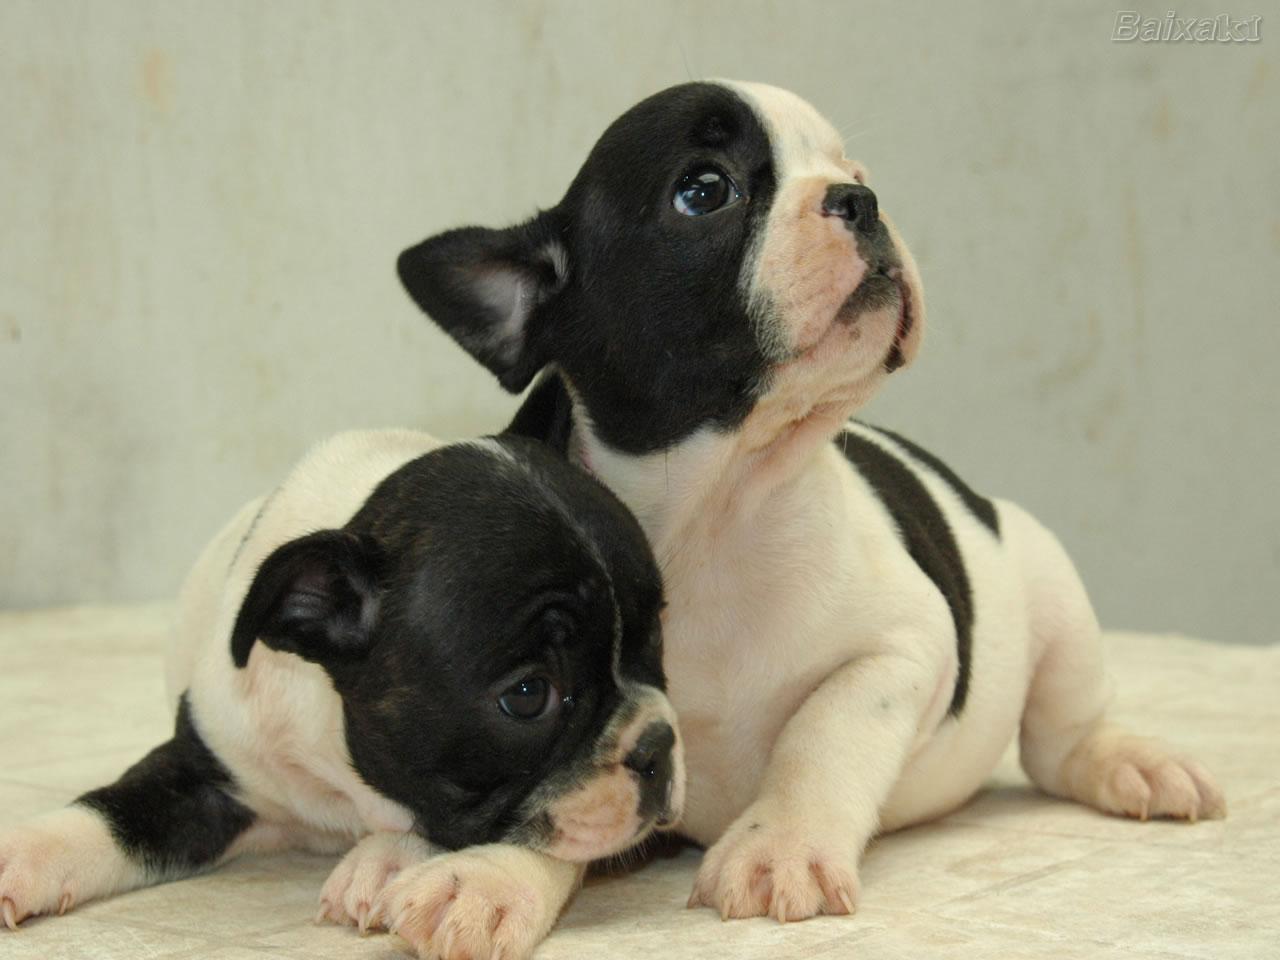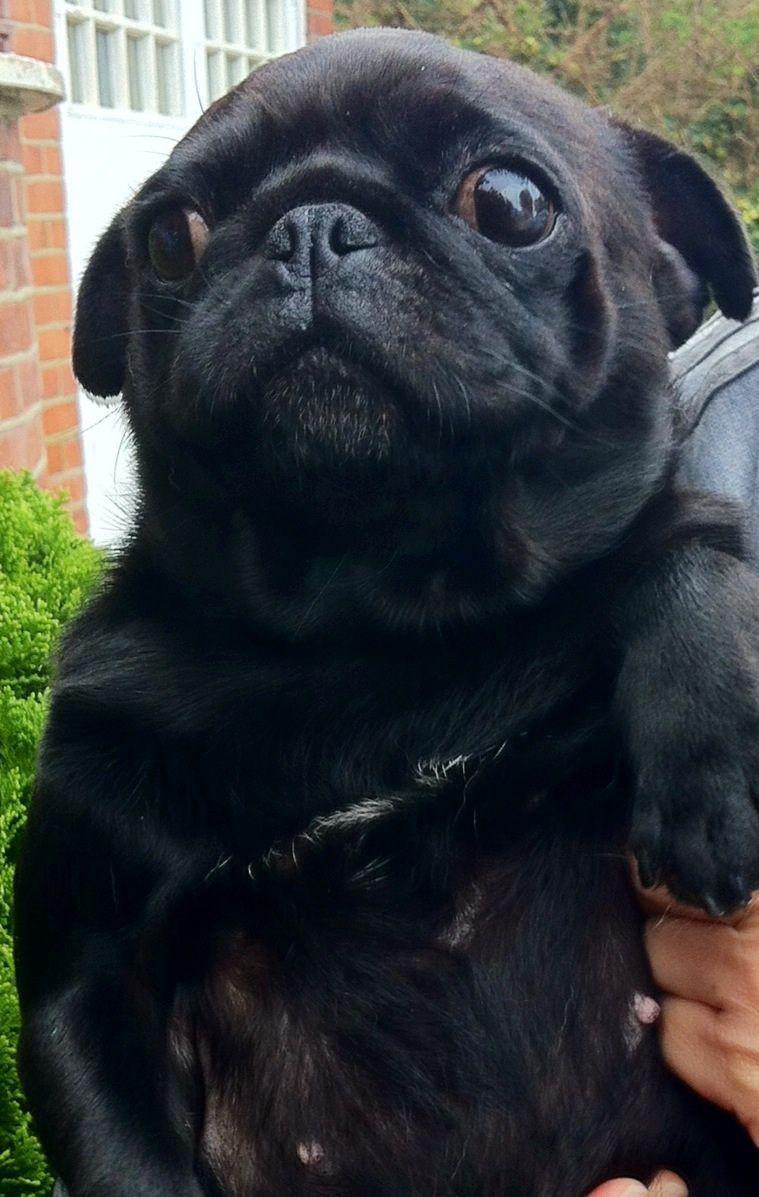The first image is the image on the left, the second image is the image on the right. Given the left and right images, does the statement "There is only one dog in each of the images." hold true? Answer yes or no. No. The first image is the image on the left, the second image is the image on the right. For the images displayed, is the sentence "The right image contains one black pug and a human hand, and no image contains a standing dog." factually correct? Answer yes or no. Yes. 